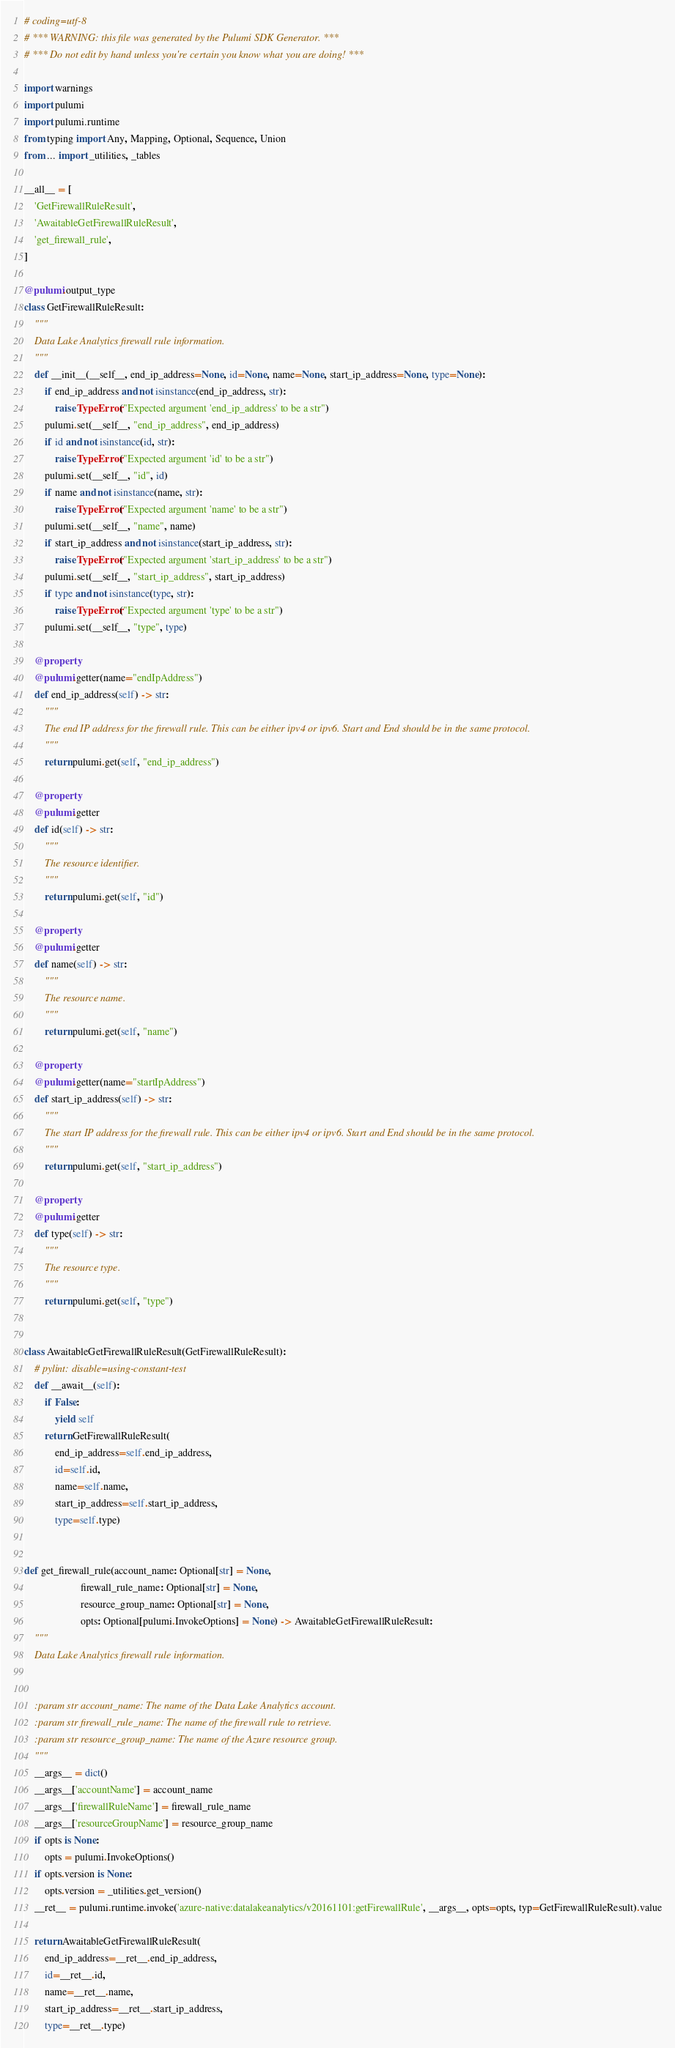Convert code to text. <code><loc_0><loc_0><loc_500><loc_500><_Python_># coding=utf-8
# *** WARNING: this file was generated by the Pulumi SDK Generator. ***
# *** Do not edit by hand unless you're certain you know what you are doing! ***

import warnings
import pulumi
import pulumi.runtime
from typing import Any, Mapping, Optional, Sequence, Union
from ... import _utilities, _tables

__all__ = [
    'GetFirewallRuleResult',
    'AwaitableGetFirewallRuleResult',
    'get_firewall_rule',
]

@pulumi.output_type
class GetFirewallRuleResult:
    """
    Data Lake Analytics firewall rule information.
    """
    def __init__(__self__, end_ip_address=None, id=None, name=None, start_ip_address=None, type=None):
        if end_ip_address and not isinstance(end_ip_address, str):
            raise TypeError("Expected argument 'end_ip_address' to be a str")
        pulumi.set(__self__, "end_ip_address", end_ip_address)
        if id and not isinstance(id, str):
            raise TypeError("Expected argument 'id' to be a str")
        pulumi.set(__self__, "id", id)
        if name and not isinstance(name, str):
            raise TypeError("Expected argument 'name' to be a str")
        pulumi.set(__self__, "name", name)
        if start_ip_address and not isinstance(start_ip_address, str):
            raise TypeError("Expected argument 'start_ip_address' to be a str")
        pulumi.set(__self__, "start_ip_address", start_ip_address)
        if type and not isinstance(type, str):
            raise TypeError("Expected argument 'type' to be a str")
        pulumi.set(__self__, "type", type)

    @property
    @pulumi.getter(name="endIpAddress")
    def end_ip_address(self) -> str:
        """
        The end IP address for the firewall rule. This can be either ipv4 or ipv6. Start and End should be in the same protocol.
        """
        return pulumi.get(self, "end_ip_address")

    @property
    @pulumi.getter
    def id(self) -> str:
        """
        The resource identifier.
        """
        return pulumi.get(self, "id")

    @property
    @pulumi.getter
    def name(self) -> str:
        """
        The resource name.
        """
        return pulumi.get(self, "name")

    @property
    @pulumi.getter(name="startIpAddress")
    def start_ip_address(self) -> str:
        """
        The start IP address for the firewall rule. This can be either ipv4 or ipv6. Start and End should be in the same protocol.
        """
        return pulumi.get(self, "start_ip_address")

    @property
    @pulumi.getter
    def type(self) -> str:
        """
        The resource type.
        """
        return pulumi.get(self, "type")


class AwaitableGetFirewallRuleResult(GetFirewallRuleResult):
    # pylint: disable=using-constant-test
    def __await__(self):
        if False:
            yield self
        return GetFirewallRuleResult(
            end_ip_address=self.end_ip_address,
            id=self.id,
            name=self.name,
            start_ip_address=self.start_ip_address,
            type=self.type)


def get_firewall_rule(account_name: Optional[str] = None,
                      firewall_rule_name: Optional[str] = None,
                      resource_group_name: Optional[str] = None,
                      opts: Optional[pulumi.InvokeOptions] = None) -> AwaitableGetFirewallRuleResult:
    """
    Data Lake Analytics firewall rule information.


    :param str account_name: The name of the Data Lake Analytics account.
    :param str firewall_rule_name: The name of the firewall rule to retrieve.
    :param str resource_group_name: The name of the Azure resource group.
    """
    __args__ = dict()
    __args__['accountName'] = account_name
    __args__['firewallRuleName'] = firewall_rule_name
    __args__['resourceGroupName'] = resource_group_name
    if opts is None:
        opts = pulumi.InvokeOptions()
    if opts.version is None:
        opts.version = _utilities.get_version()
    __ret__ = pulumi.runtime.invoke('azure-native:datalakeanalytics/v20161101:getFirewallRule', __args__, opts=opts, typ=GetFirewallRuleResult).value

    return AwaitableGetFirewallRuleResult(
        end_ip_address=__ret__.end_ip_address,
        id=__ret__.id,
        name=__ret__.name,
        start_ip_address=__ret__.start_ip_address,
        type=__ret__.type)
</code> 